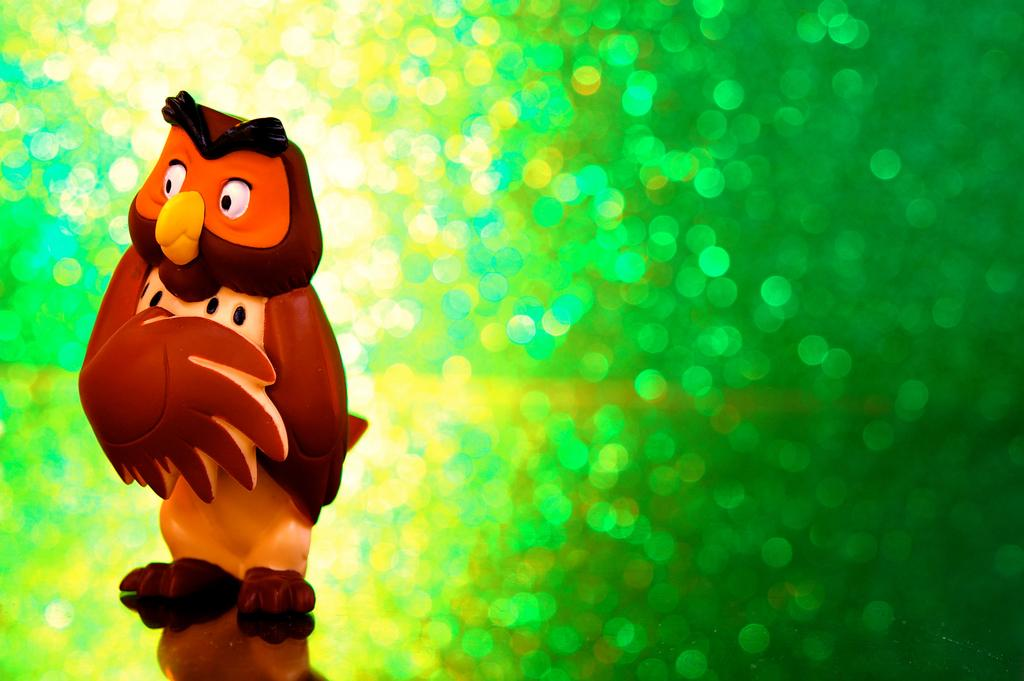What object can be seen in the image? There is a toy in the image. What colors are used for the background of the toy? The background of the toy is in green and yellow colors. Is there a rifle visible in the image? No, there is no rifle present in the image. What type of market is depicted in the image? There is no market present in the image; it features a toy with a green and yellow background. 